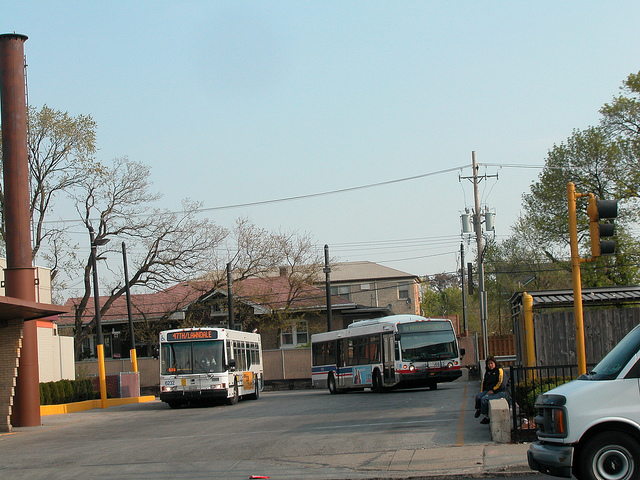Identify and read out the text in this image. 4TTH/LAHNDALE 